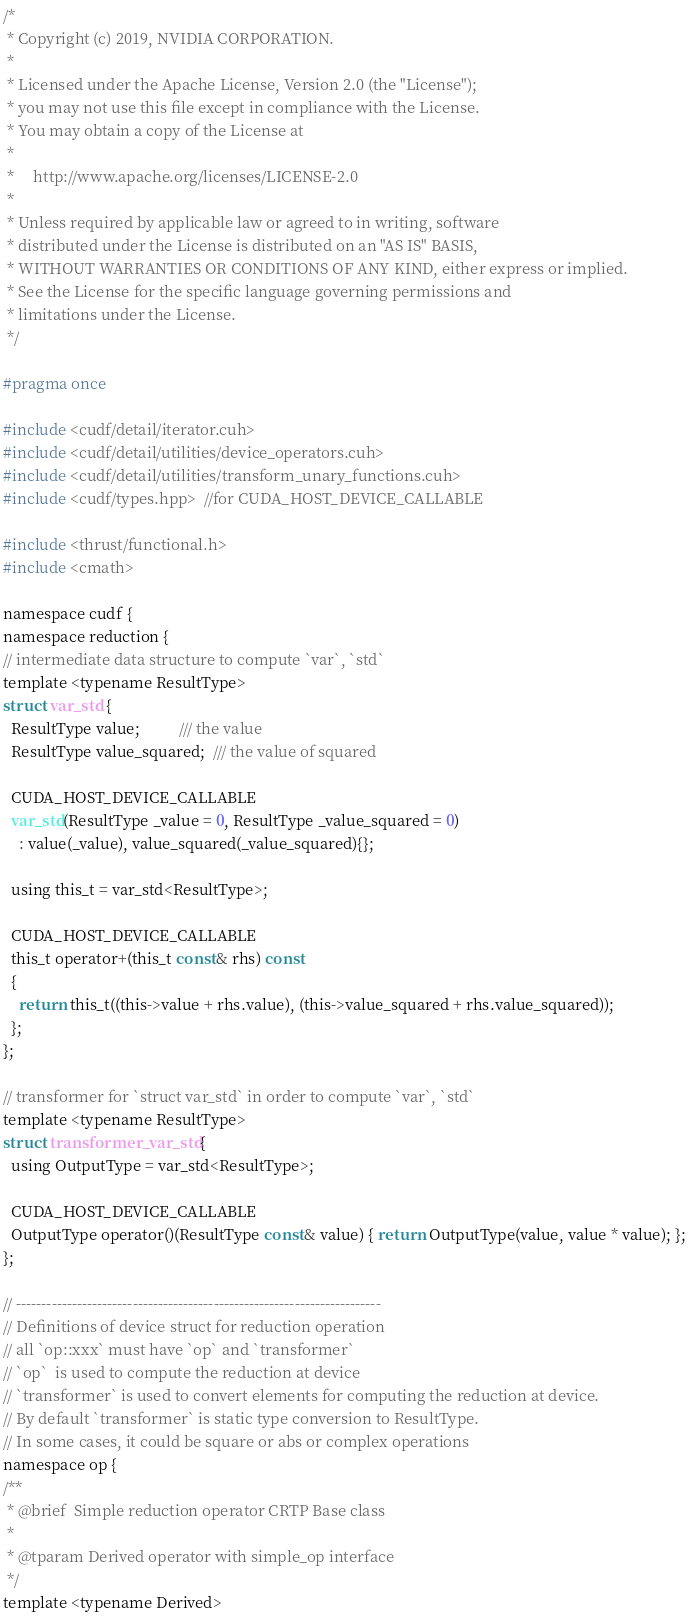<code> <loc_0><loc_0><loc_500><loc_500><_Cuda_>/*
 * Copyright (c) 2019, NVIDIA CORPORATION.
 *
 * Licensed under the Apache License, Version 2.0 (the "License");
 * you may not use this file except in compliance with the License.
 * You may obtain a copy of the License at
 *
 *     http://www.apache.org/licenses/LICENSE-2.0
 *
 * Unless required by applicable law or agreed to in writing, software
 * distributed under the License is distributed on an "AS IS" BASIS,
 * WITHOUT WARRANTIES OR CONDITIONS OF ANY KIND, either express or implied.
 * See the License for the specific language governing permissions and
 * limitations under the License.
 */

#pragma once

#include <cudf/detail/iterator.cuh>
#include <cudf/detail/utilities/device_operators.cuh>
#include <cudf/detail/utilities/transform_unary_functions.cuh>
#include <cudf/types.hpp>  //for CUDA_HOST_DEVICE_CALLABLE

#include <thrust/functional.h>
#include <cmath>

namespace cudf {
namespace reduction {
// intermediate data structure to compute `var`, `std`
template <typename ResultType>
struct var_std {
  ResultType value;          /// the value
  ResultType value_squared;  /// the value of squared

  CUDA_HOST_DEVICE_CALLABLE
  var_std(ResultType _value = 0, ResultType _value_squared = 0)
    : value(_value), value_squared(_value_squared){};

  using this_t = var_std<ResultType>;

  CUDA_HOST_DEVICE_CALLABLE
  this_t operator+(this_t const& rhs) const
  {
    return this_t((this->value + rhs.value), (this->value_squared + rhs.value_squared));
  };
};

// transformer for `struct var_std` in order to compute `var`, `std`
template <typename ResultType>
struct transformer_var_std {
  using OutputType = var_std<ResultType>;

  CUDA_HOST_DEVICE_CALLABLE
  OutputType operator()(ResultType const& value) { return OutputType(value, value * value); };
};

// ------------------------------------------------------------------------
// Definitions of device struct for reduction operation
// all `op::xxx` must have `op` and `transformer`
// `op`  is used to compute the reduction at device
// `transformer` is used to convert elements for computing the reduction at device.
// By default `transformer` is static type conversion to ResultType.
// In some cases, it could be square or abs or complex operations
namespace op {
/**
 * @brief  Simple reduction operator CRTP Base class
 *
 * @tparam Derived operator with simple_op interface
 */
template <typename Derived></code> 